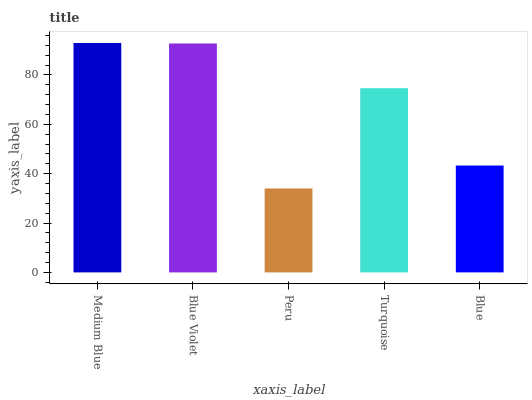Is Peru the minimum?
Answer yes or no. Yes. Is Medium Blue the maximum?
Answer yes or no. Yes. Is Blue Violet the minimum?
Answer yes or no. No. Is Blue Violet the maximum?
Answer yes or no. No. Is Medium Blue greater than Blue Violet?
Answer yes or no. Yes. Is Blue Violet less than Medium Blue?
Answer yes or no. Yes. Is Blue Violet greater than Medium Blue?
Answer yes or no. No. Is Medium Blue less than Blue Violet?
Answer yes or no. No. Is Turquoise the high median?
Answer yes or no. Yes. Is Turquoise the low median?
Answer yes or no. Yes. Is Medium Blue the high median?
Answer yes or no. No. Is Medium Blue the low median?
Answer yes or no. No. 